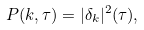Convert formula to latex. <formula><loc_0><loc_0><loc_500><loc_500>P ( k , \tau ) = | \delta _ { k } | ^ { 2 } ( \tau ) ,</formula> 